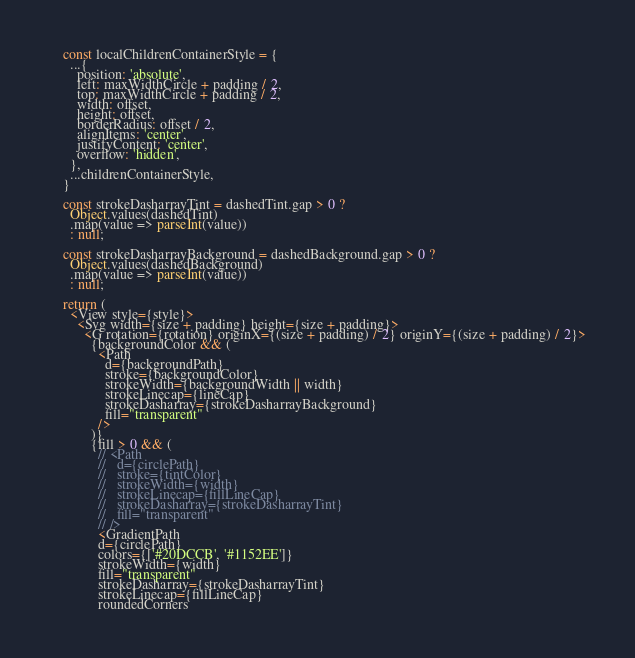<code> <loc_0><loc_0><loc_500><loc_500><_JavaScript_>
    const localChildrenContainerStyle = {
      ...{
        position: 'absolute',
        left: maxWidthCircle + padding / 2,
        top: maxWidthCircle + padding / 2,
        width: offset,
        height: offset,
        borderRadius: offset / 2,
        alignItems: 'center',
        justifyContent: 'center',
        overflow: 'hidden',
      },
      ...childrenContainerStyle,
    }

    const strokeDasharrayTint = dashedTint.gap > 0 ?
      Object.values(dashedTint)
      .map(value => parseInt(value))
      : null;

    const strokeDasharrayBackground = dashedBackground.gap > 0 ?
      Object.values(dashedBackground)
      .map(value => parseInt(value))
      : null;

    return (
      <View style={style}>
        <Svg width={size + padding} height={size + padding}>
          <G rotation={rotation} originX={(size + padding) / 2} originY={(size + padding) / 2}>
            {backgroundColor && (
              <Path
                d={backgroundPath}
                stroke={backgroundColor}
                strokeWidth={backgroundWidth || width}
                strokeLinecap={lineCap}
                strokeDasharray={strokeDasharrayBackground}
                fill="transparent"
              />
            )}
            {fill > 0 && (
              // <Path
              //   d={circlePath}
              //   stroke={tintColor}
              //   strokeWidth={width}
              //   strokeLinecap={fillLineCap}
              //   strokeDasharray={strokeDasharrayTint}
              //   fill="transparent"
              // />
              <GradientPath
              d={circlePath}
              colors={['#20DCCB', '#1152EE']}
              strokeWidth={width}
              fill="transparent"
              strokeDasharray={strokeDasharrayTint}
              strokeLinecap={fillLineCap}
              roundedCorners</code> 